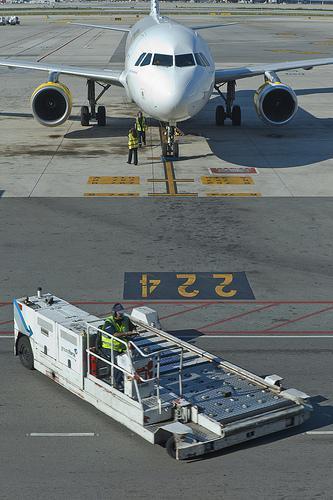How many numbers are on the ground?
Give a very brief answer. 3. 